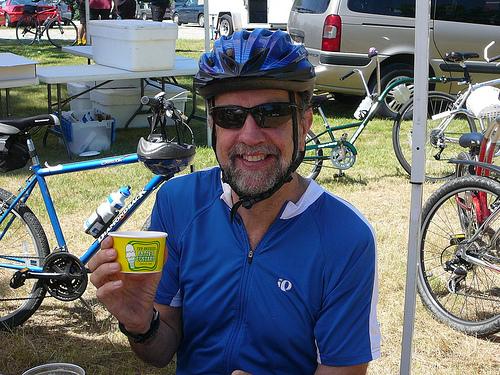Did the man take this picture himself?
Write a very short answer. No. Are these people riding bikes?
Write a very short answer. Yes. Is he wearing a helmet?
Give a very brief answer. Yes. What kind of food does the man have?
Concise answer only. Ice cream. 